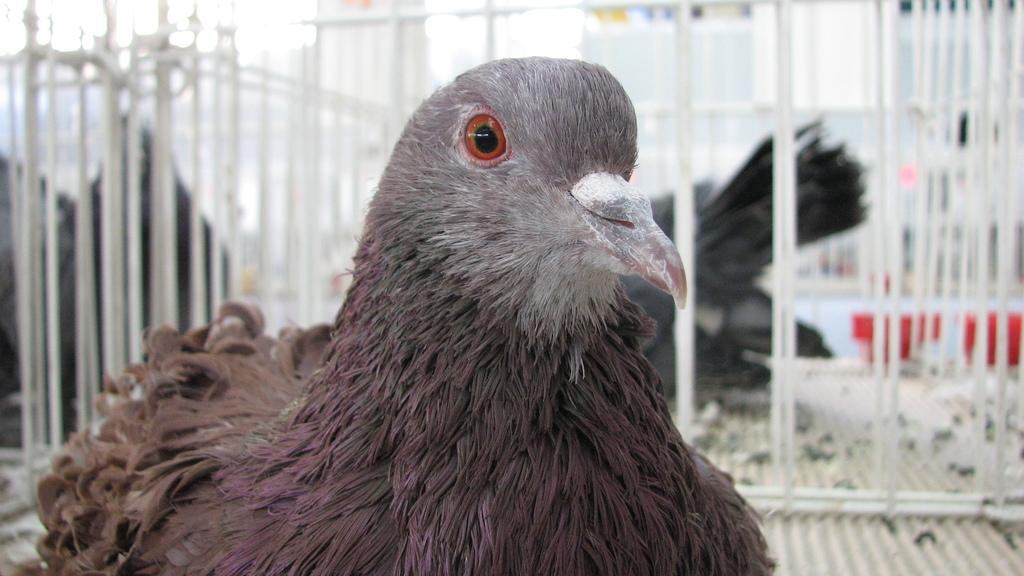What type of animals can be seen in the image? Birds can be seen in the image. What material are the rods in the image made of? The rods in the image are made of metal. What color is the orange kettle in the image? There is no orange kettle present in the image. Is the hot tea visible in the image? There is no tea, hot or otherwise, visible in the image. 